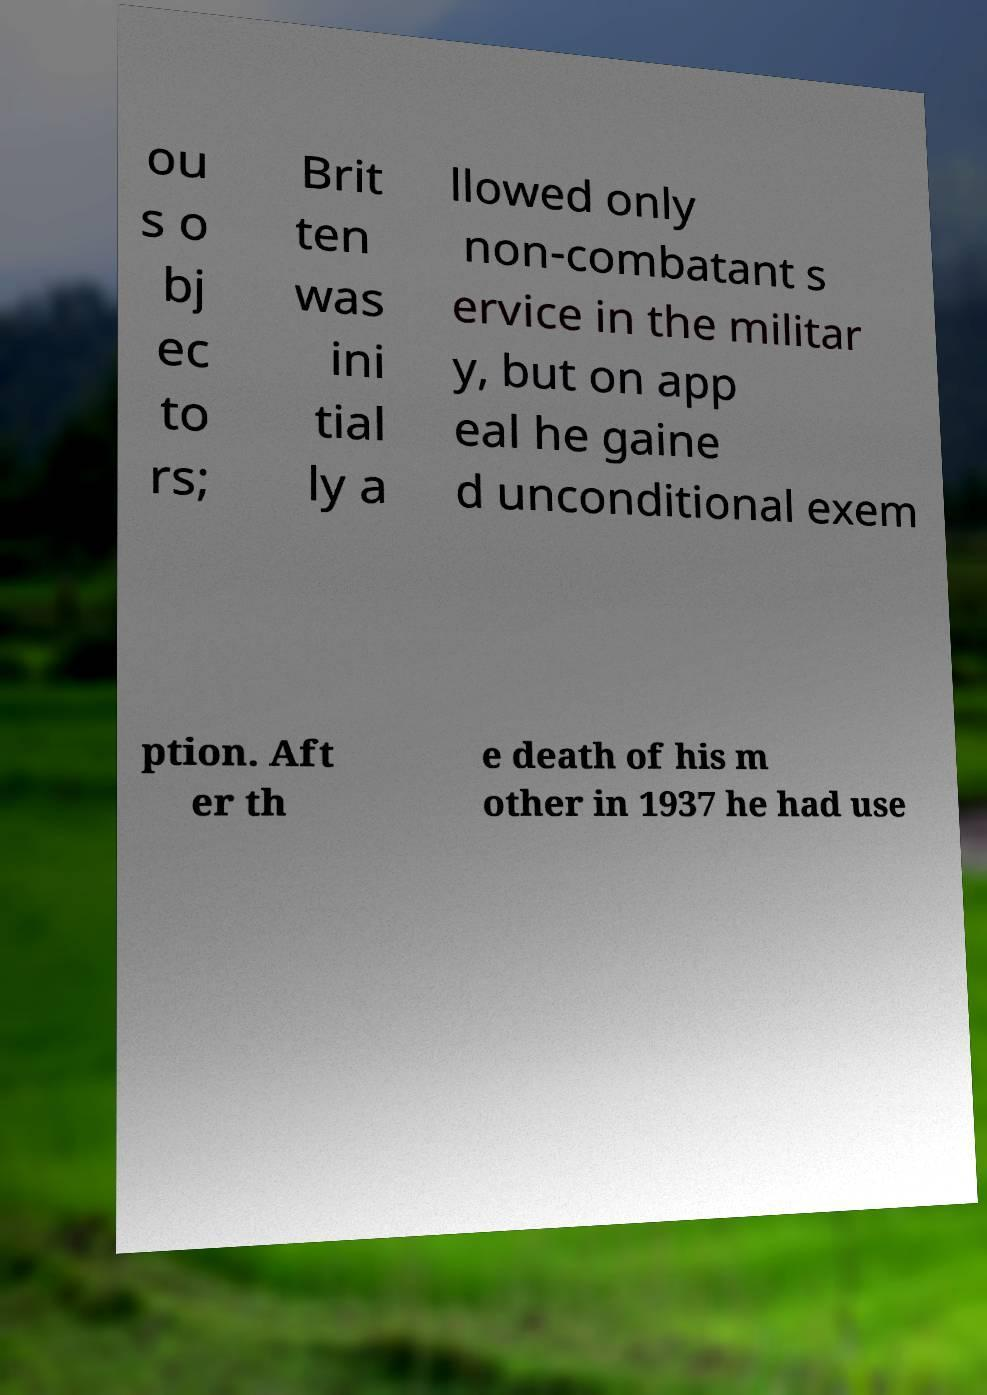For documentation purposes, I need the text within this image transcribed. Could you provide that? ou s o bj ec to rs; Brit ten was ini tial ly a llowed only non-combatant s ervice in the militar y, but on app eal he gaine d unconditional exem ption. Aft er th e death of his m other in 1937 he had use 